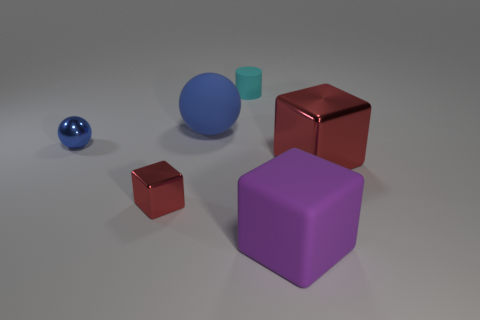What color is the other thing that is the same shape as the blue metal thing?
Your answer should be compact. Blue. The other red thing that is the same shape as the big red metallic thing is what size?
Ensure brevity in your answer.  Small. There is a small thing that is behind the blue thing that is to the right of the blue metal ball that is in front of the cyan thing; what is its material?
Ensure brevity in your answer.  Rubber. What number of things are tiny cyan rubber things or tiny green matte balls?
Your response must be concise. 1. There is a small thing in front of the small blue object; does it have the same color as the metal thing that is on the right side of the tiny cylinder?
Your answer should be compact. Yes. What shape is the blue object that is the same size as the cylinder?
Keep it short and to the point. Sphere. What number of things are either blue things to the right of the tiny blue ball or purple matte objects to the right of the big rubber sphere?
Provide a succinct answer. 2. Is the number of small gray metallic balls less than the number of large metallic things?
Your answer should be very brief. Yes. What is the material of the red thing that is the same size as the purple thing?
Give a very brief answer. Metal. There is a sphere that is behind the tiny shiny ball; is it the same size as the red object that is on the left side of the cyan rubber cylinder?
Offer a terse response. No. 